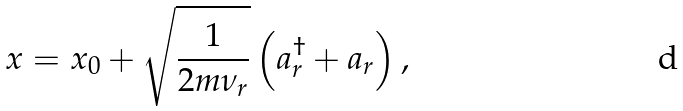<formula> <loc_0><loc_0><loc_500><loc_500>x = x _ { 0 } + \sqrt { \frac { 1 } { 2 m \nu _ { r } } } \left ( a _ { r } ^ { \dagger } + a _ { r } \right ) ,</formula> 